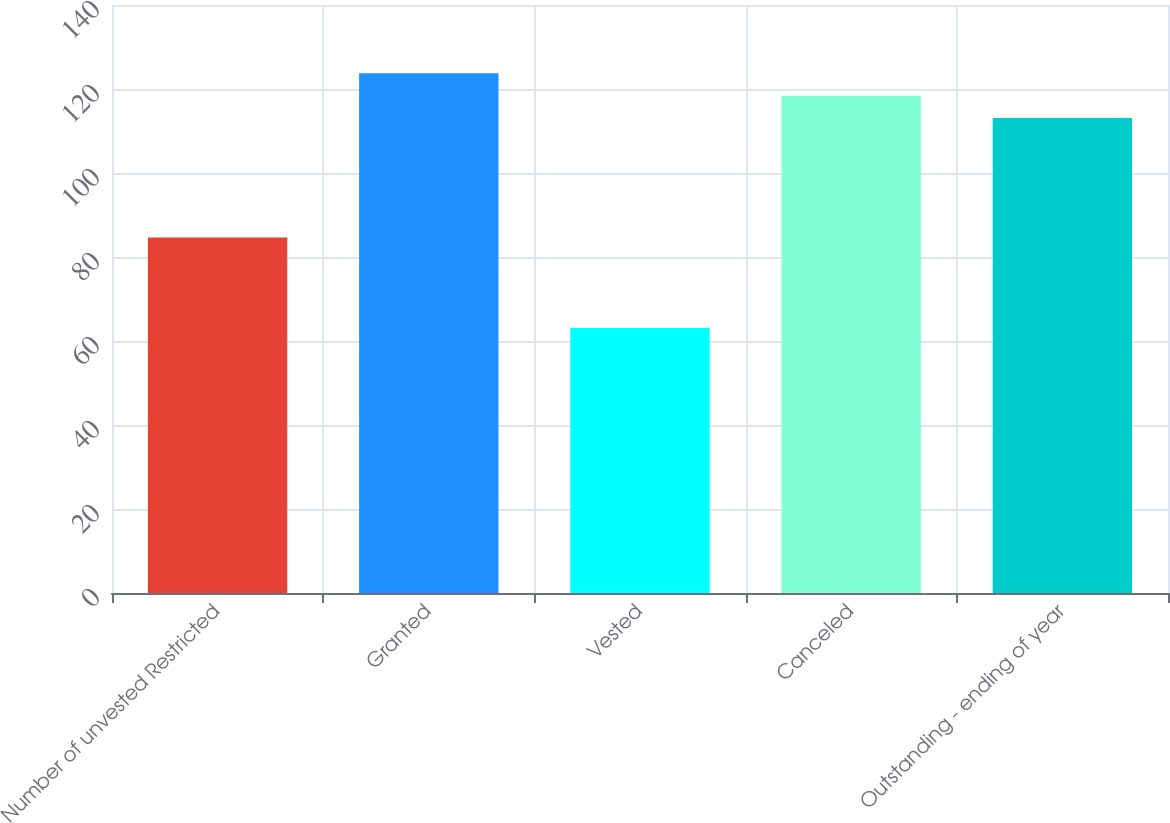Convert chart to OTSL. <chart><loc_0><loc_0><loc_500><loc_500><bar_chart><fcel>Number of unvested Restricted<fcel>Granted<fcel>Vested<fcel>Canceled<fcel>Outstanding - ending of year<nl><fcel>84.62<fcel>123.73<fcel>63.07<fcel>118.41<fcel>113.09<nl></chart> 